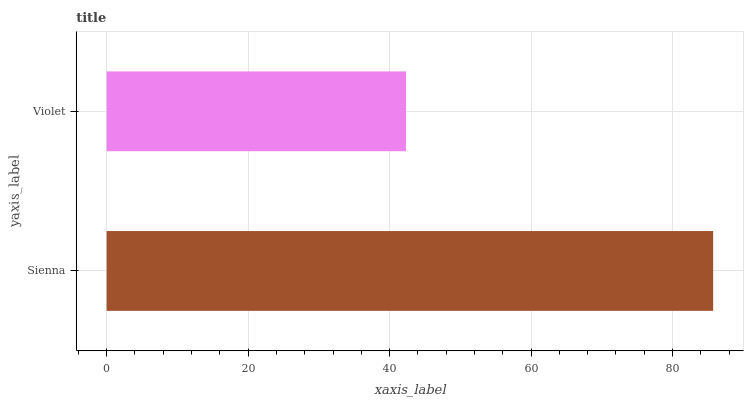Is Violet the minimum?
Answer yes or no. Yes. Is Sienna the maximum?
Answer yes or no. Yes. Is Violet the maximum?
Answer yes or no. No. Is Sienna greater than Violet?
Answer yes or no. Yes. Is Violet less than Sienna?
Answer yes or no. Yes. Is Violet greater than Sienna?
Answer yes or no. No. Is Sienna less than Violet?
Answer yes or no. No. Is Sienna the high median?
Answer yes or no. Yes. Is Violet the low median?
Answer yes or no. Yes. Is Violet the high median?
Answer yes or no. No. Is Sienna the low median?
Answer yes or no. No. 